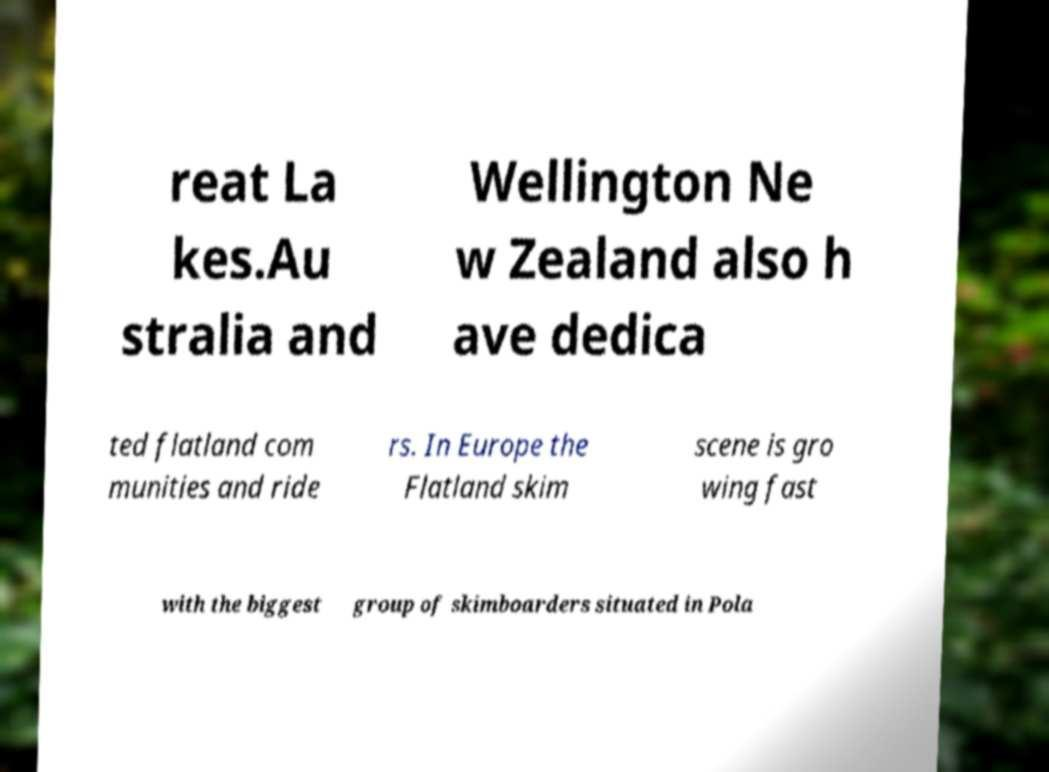Please identify and transcribe the text found in this image. reat La kes.Au stralia and Wellington Ne w Zealand also h ave dedica ted flatland com munities and ride rs. In Europe the Flatland skim scene is gro wing fast with the biggest group of skimboarders situated in Pola 